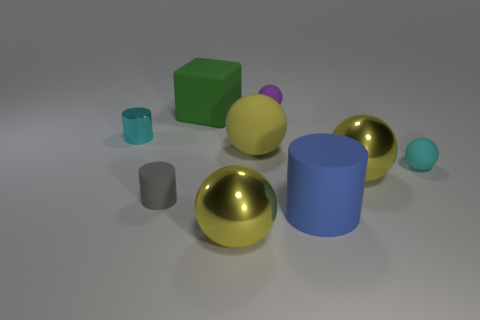What can you infer about the material characteristics of the objects shown? Based on their appearance, the objects seem to be made of different materials. The gold spheres have a metallic finish, suggesting they could be made of metal or a similarly lustrous material. The matte objects, including the green cube, the gray cylinder, and the smaller blue cylinder, may be made of a plastic or rubber-like substance, indicated by their diffuse surface which doesn't reflect light as strongly. The matte purple and light blue spheres likely share this characteristic. 